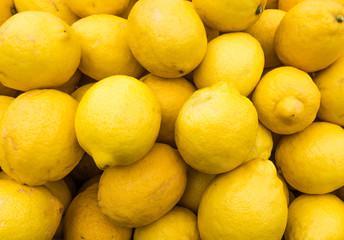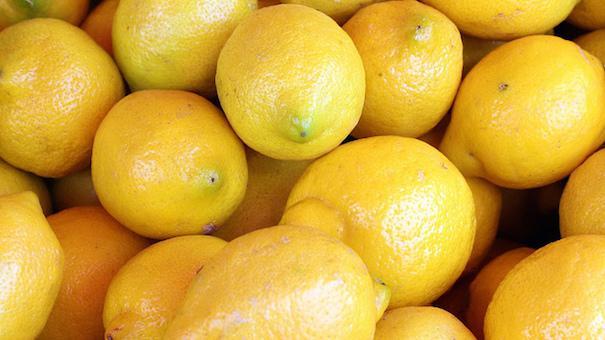The first image is the image on the left, the second image is the image on the right. For the images displayed, is the sentence "There are only whole uncut lemons in the left image." factually correct? Answer yes or no. Yes. The first image is the image on the left, the second image is the image on the right. Analyze the images presented: Is the assertion "The combined images include at least one cut lemon half and multiple whole lemons, but no lemons are in a container." valid? Answer yes or no. No. 